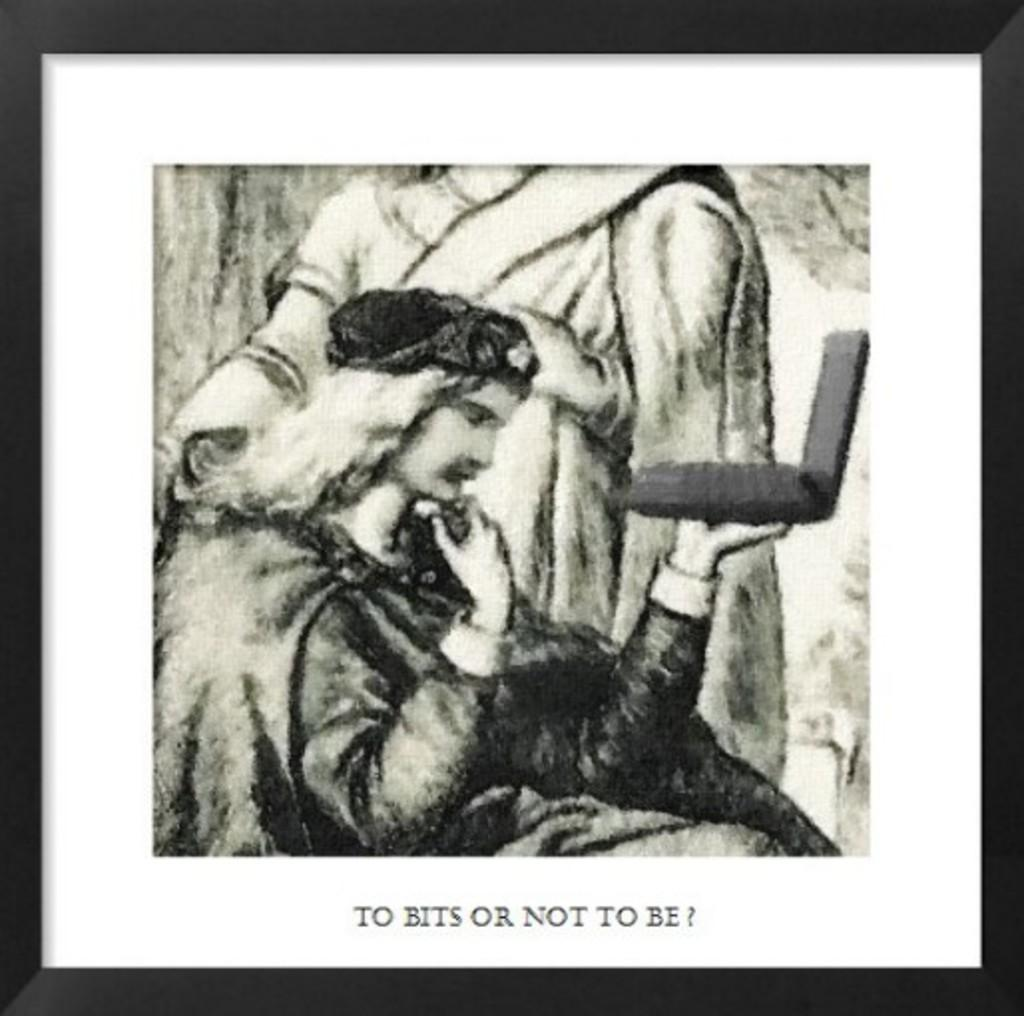What object is present in the image that typically holds a picture? There is a photo frame in the image. What can be seen inside the photo frame? The photo frame contains a picture of a woman and a picture of a person holding a laptop. How many frogs are jumping around in the photo frame? There are no frogs present in the image, as it features a photo frame with two pictures inside. 